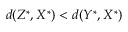<formula> <loc_0><loc_0><loc_500><loc_500>d ( Z ^ { \ast } , X ^ { \ast } ) < d ( Y ^ { \ast } , X ^ { \ast } )</formula> 